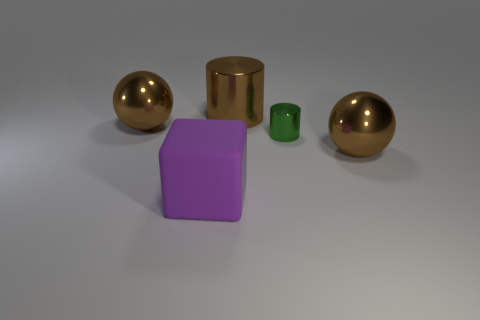Add 5 tiny red metallic cubes. How many objects exist? 10 Subtract all cubes. How many objects are left? 4 Add 2 metal balls. How many metal balls are left? 4 Add 5 big shiny balls. How many big shiny balls exist? 7 Subtract 0 brown blocks. How many objects are left? 5 Subtract all cylinders. Subtract all big purple blocks. How many objects are left? 2 